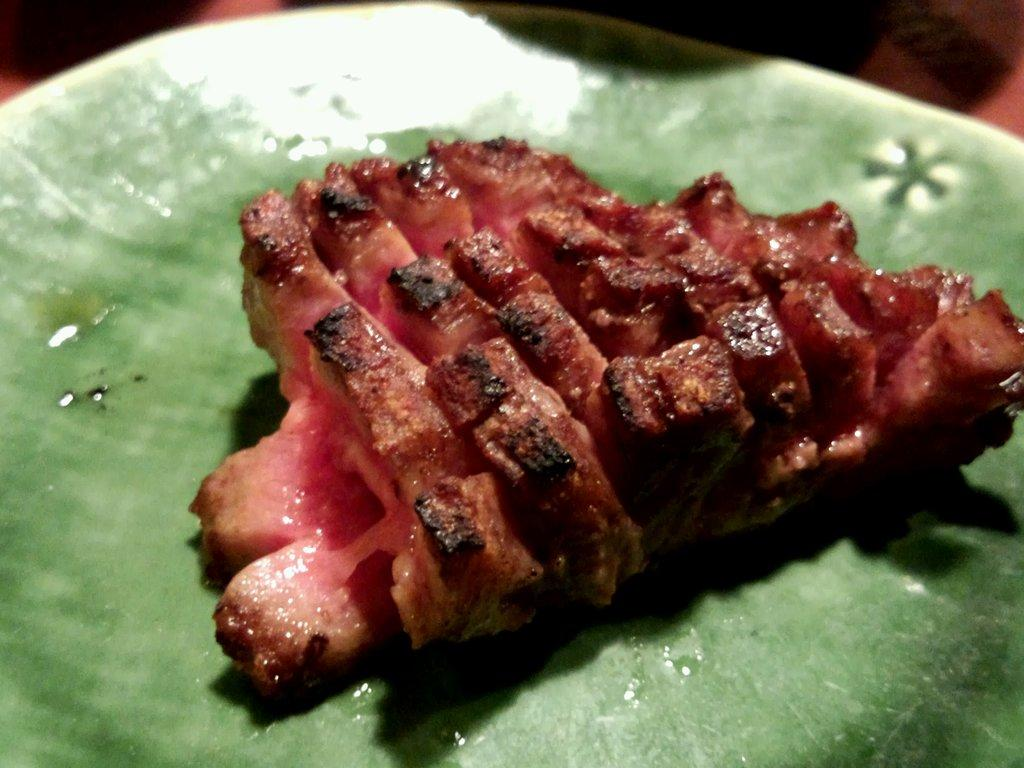What is present on the plate in the image? There is food in a plate in the image. How many bikes are being used to support the plate in the image? There are no bikes present in the image, and therefore they cannot be used to support the plate. 